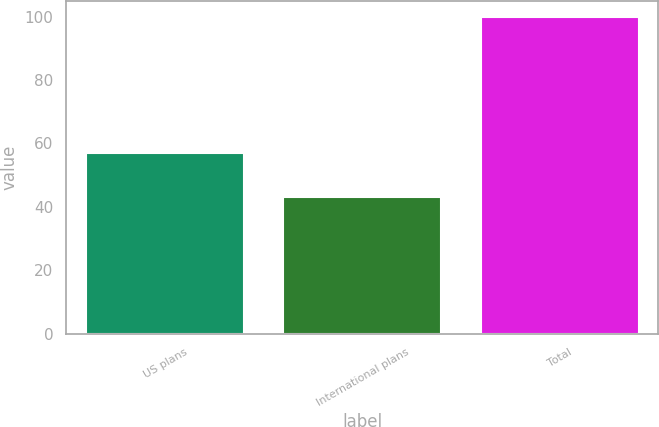Convert chart. <chart><loc_0><loc_0><loc_500><loc_500><bar_chart><fcel>US plans<fcel>International plans<fcel>Total<nl><fcel>57<fcel>43<fcel>100<nl></chart> 